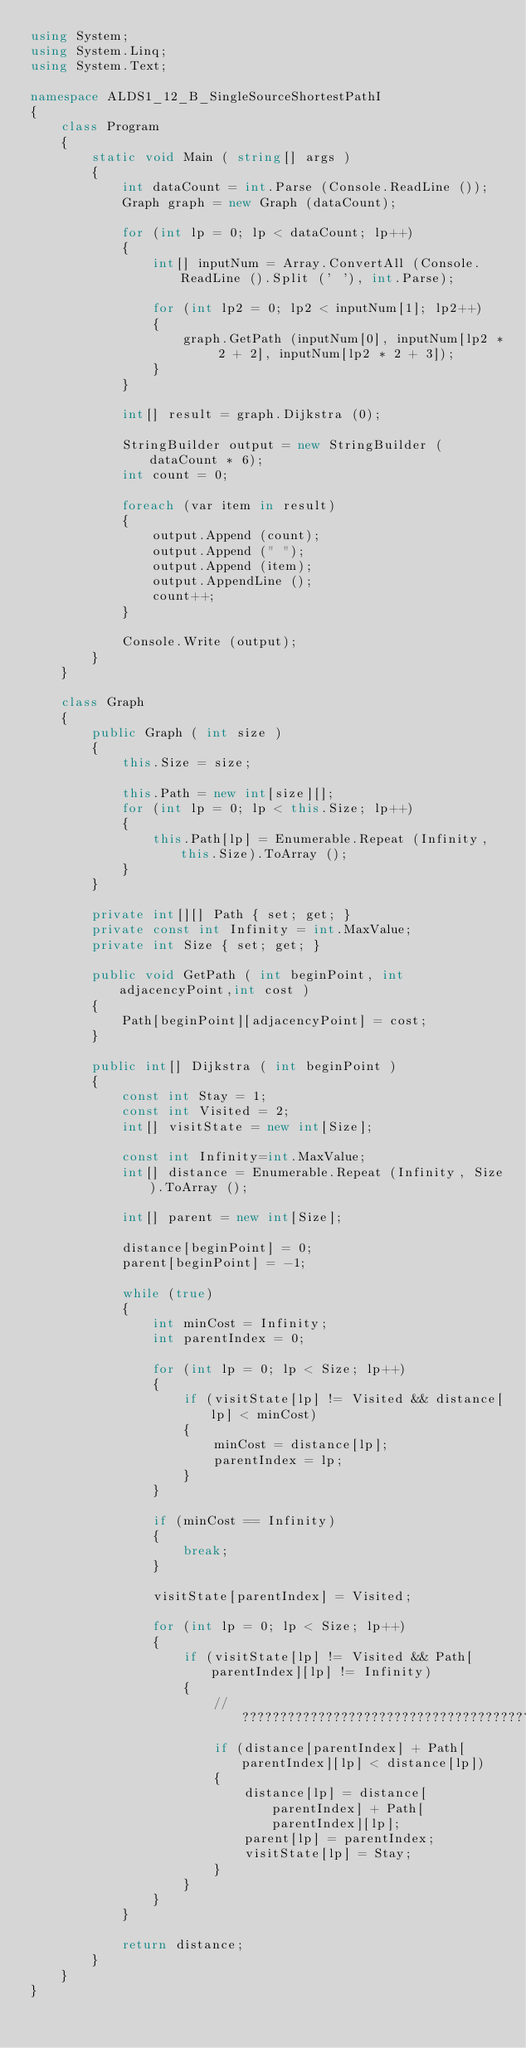<code> <loc_0><loc_0><loc_500><loc_500><_C#_>using System;
using System.Linq;
using System.Text;

namespace ALDS1_12_B_SingleSourceShortestPathI
{
	class Program
	{
		static void Main ( string[] args )
		{
			int dataCount = int.Parse (Console.ReadLine ());
			Graph graph = new Graph (dataCount);

			for (int lp = 0; lp < dataCount; lp++)
			{
				int[] inputNum = Array.ConvertAll (Console.ReadLine ().Split (' '), int.Parse);

				for (int lp2 = 0; lp2 < inputNum[1]; lp2++)
				{
					graph.GetPath (inputNum[0], inputNum[lp2 * 2 + 2], inputNum[lp2 * 2 + 3]);
				}
			}

			int[] result = graph.Dijkstra (0);

			StringBuilder output = new StringBuilder (dataCount * 6);
			int count = 0;

			foreach (var item in result)
			{
				output.Append (count);
				output.Append (" ");
				output.Append (item);
				output.AppendLine ();
				count++;
			}

			Console.Write (output);
		}
	}

	class Graph
	{
		public Graph ( int size )
		{
			this.Size = size;

			this.Path = new int[size][];
			for (int lp = 0; lp < this.Size; lp++)
			{
				this.Path[lp] = Enumerable.Repeat (Infinity, this.Size).ToArray ();
			}
		}

		private int[][] Path { set; get; }
		private const int Infinity = int.MaxValue;
		private int Size { set; get; }	

		public void GetPath ( int beginPoint, int adjacencyPoint,int cost )
		{
			Path[beginPoint][adjacencyPoint] = cost;
		}

		public int[] Dijkstra ( int beginPoint )
		{
			const int Stay = 1;
			const int Visited = 2;
			int[] visitState = new int[Size];

			const int Infinity=int.MaxValue;
			int[] distance = Enumerable.Repeat (Infinity, Size).ToArray ();

			int[] parent = new int[Size];

			distance[beginPoint] = 0;
			parent[beginPoint] = -1;

			while (true)
			{
				int minCost = Infinity;
				int parentIndex = 0;

				for (int lp = 0; lp < Size; lp++)
				{
					if (visitState[lp] != Visited && distance[lp] < minCost)
					{
						minCost = distance[lp];
						parentIndex = lp;
					}
				}

				if (minCost == Infinity)
				{
					break;
				}

				visitState[parentIndex] = Visited;

				for (int lp = 0; lp < Size; lp++)
				{
					if (visitState[lp] != Visited && Path[parentIndex][lp] != Infinity)
					{
						//?????????????????????????????????????????????
						if (distance[parentIndex] + Path[parentIndex][lp] < distance[lp])
						{
							distance[lp] = distance[parentIndex] + Path[parentIndex][lp];
							parent[lp] = parentIndex;
							visitState[lp] = Stay;
						}
					}
				}
			}

			return distance;
		}
	}
}</code> 